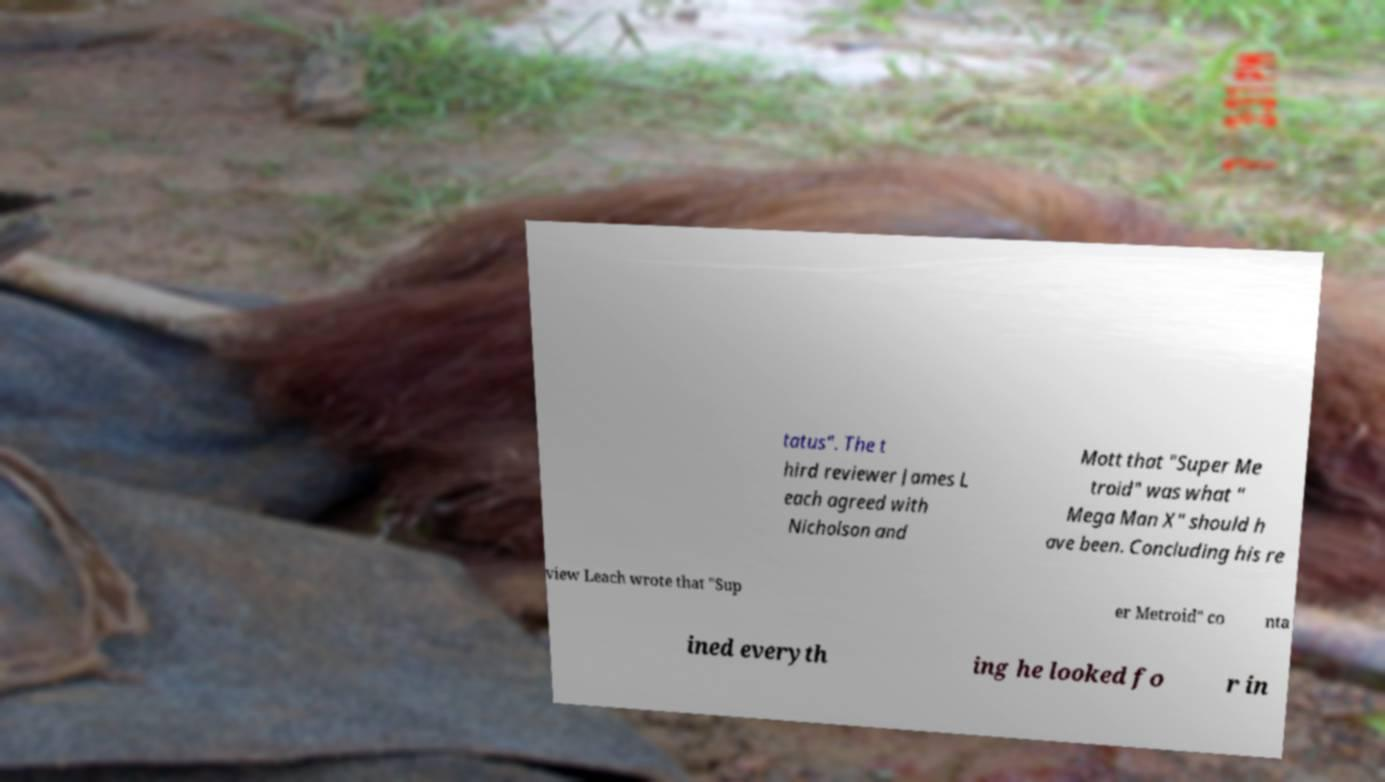There's text embedded in this image that I need extracted. Can you transcribe it verbatim? tatus". The t hird reviewer James L each agreed with Nicholson and Mott that "Super Me troid" was what " Mega Man X" should h ave been. Concluding his re view Leach wrote that "Sup er Metroid" co nta ined everyth ing he looked fo r in 